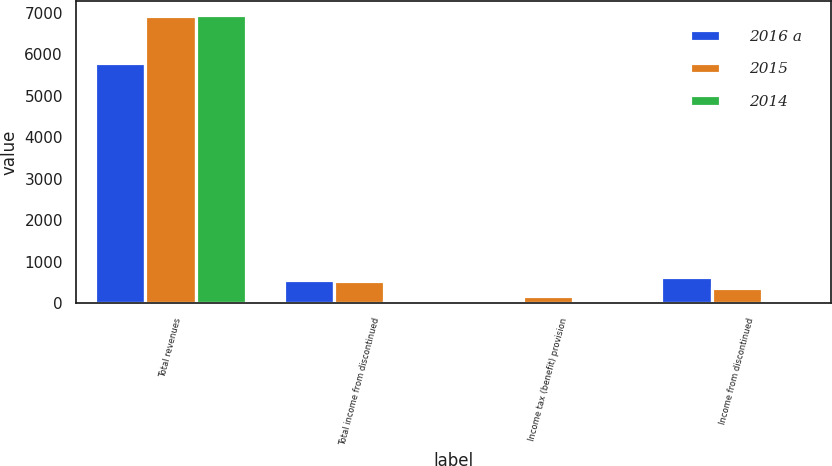Convert chart to OTSL. <chart><loc_0><loc_0><loc_500><loc_500><stacked_bar_chart><ecel><fcel>Total revenues<fcel>Total income from discontinued<fcel>Income tax (benefit) provision<fcel>Income from discontinued<nl><fcel>2016 a<fcel>5776<fcel>571<fcel>65<fcel>625<nl><fcel>2015<fcel>6909<fcel>526<fcel>164<fcel>357<nl><fcel>2014<fcel>6934<fcel>53<fcel>38<fcel>45<nl></chart> 